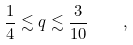Convert formula to latex. <formula><loc_0><loc_0><loc_500><loc_500>\frac { 1 } { 4 } \lesssim q \lesssim \frac { 3 } { 1 0 } \quad ,</formula> 